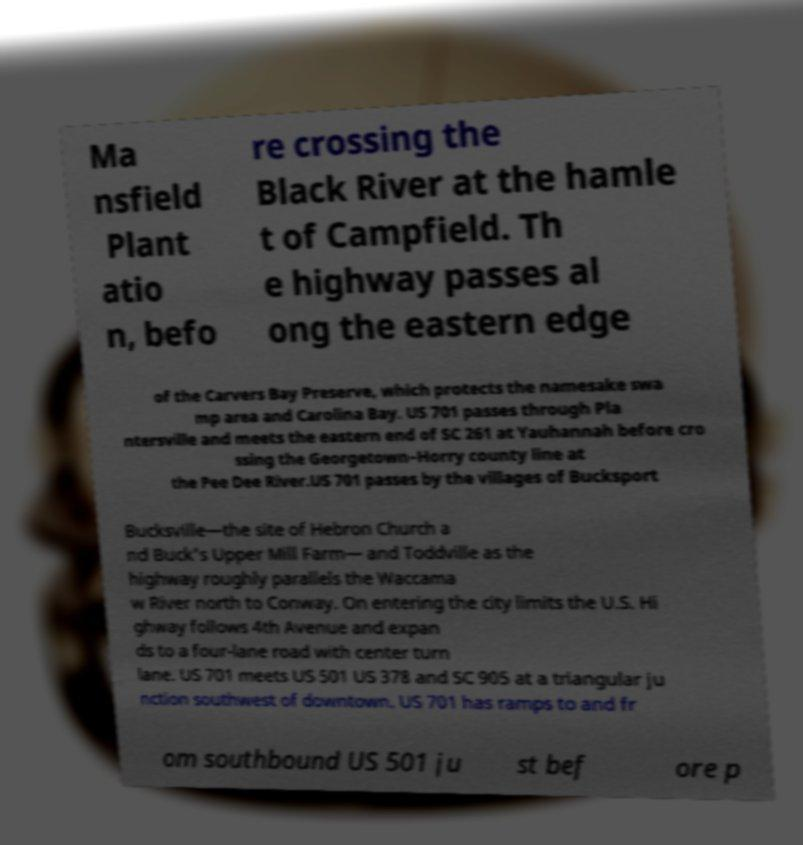Could you extract and type out the text from this image? Ma nsfield Plant atio n, befo re crossing the Black River at the hamle t of Campfield. Th e highway passes al ong the eastern edge of the Carvers Bay Preserve, which protects the namesake swa mp area and Carolina Bay. US 701 passes through Pla ntersville and meets the eastern end of SC 261 at Yauhannah before cro ssing the Georgetown–Horry county line at the Pee Dee River.US 701 passes by the villages of Bucksport Bucksville—the site of Hebron Church a nd Buck's Upper Mill Farm— and Toddville as the highway roughly parallels the Waccama w River north to Conway. On entering the city limits the U.S. Hi ghway follows 4th Avenue and expan ds to a four-lane road with center turn lane. US 701 meets US 501 US 378 and SC 905 at a triangular ju nction southwest of downtown. US 701 has ramps to and fr om southbound US 501 ju st bef ore p 